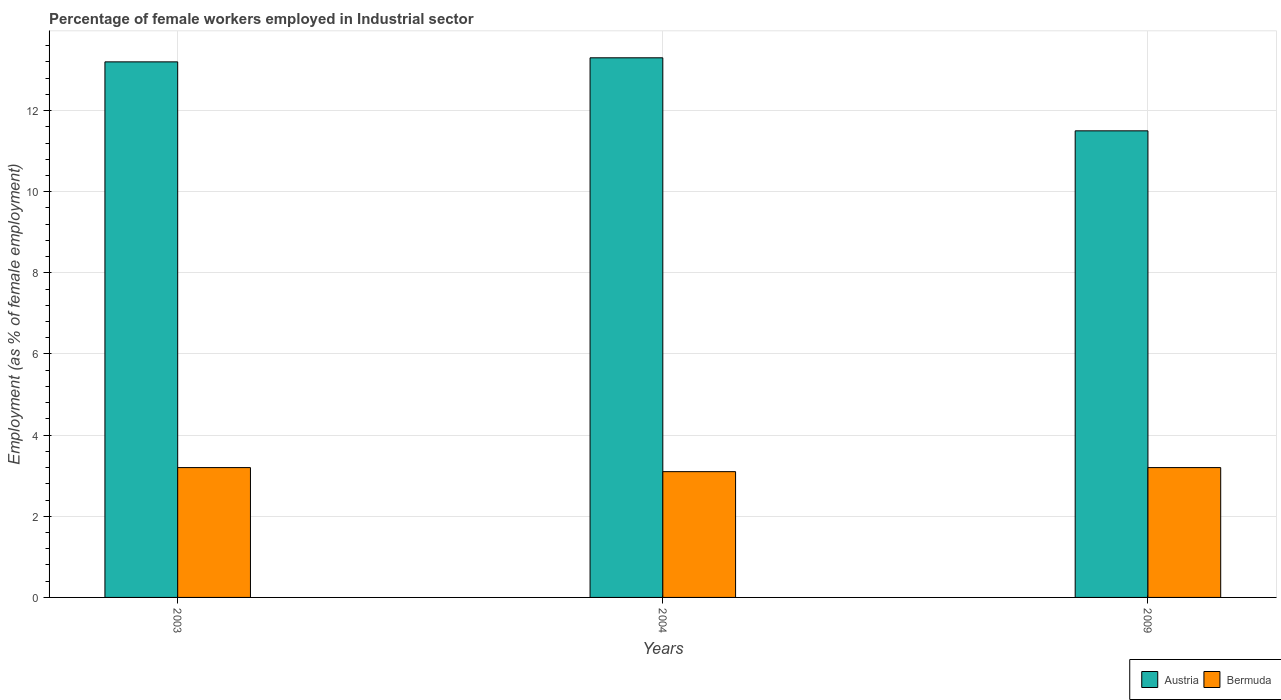How many groups of bars are there?
Offer a very short reply. 3. Are the number of bars on each tick of the X-axis equal?
Offer a very short reply. Yes. How many bars are there on the 1st tick from the right?
Your response must be concise. 2. In how many cases, is the number of bars for a given year not equal to the number of legend labels?
Make the answer very short. 0. What is the percentage of females employed in Industrial sector in Austria in 2003?
Keep it short and to the point. 13.2. Across all years, what is the maximum percentage of females employed in Industrial sector in Austria?
Your answer should be very brief. 13.3. Across all years, what is the minimum percentage of females employed in Industrial sector in Austria?
Ensure brevity in your answer.  11.5. In which year was the percentage of females employed in Industrial sector in Bermuda maximum?
Ensure brevity in your answer.  2003. In which year was the percentage of females employed in Industrial sector in Bermuda minimum?
Your response must be concise. 2004. What is the difference between the percentage of females employed in Industrial sector in Bermuda in 2004 and that in 2009?
Ensure brevity in your answer.  -0.1. What is the difference between the percentage of females employed in Industrial sector in Bermuda in 2003 and the percentage of females employed in Industrial sector in Austria in 2004?
Provide a short and direct response. -10.1. What is the average percentage of females employed in Industrial sector in Bermuda per year?
Your response must be concise. 3.17. In the year 2009, what is the difference between the percentage of females employed in Industrial sector in Bermuda and percentage of females employed in Industrial sector in Austria?
Offer a terse response. -8.3. In how many years, is the percentage of females employed in Industrial sector in Austria greater than 12.8 %?
Provide a succinct answer. 2. What is the ratio of the percentage of females employed in Industrial sector in Austria in 2004 to that in 2009?
Your answer should be very brief. 1.16. Is the difference between the percentage of females employed in Industrial sector in Bermuda in 2003 and 2009 greater than the difference between the percentage of females employed in Industrial sector in Austria in 2003 and 2009?
Make the answer very short. No. What is the difference between the highest and the second highest percentage of females employed in Industrial sector in Austria?
Your answer should be compact. 0.1. What is the difference between the highest and the lowest percentage of females employed in Industrial sector in Austria?
Offer a terse response. 1.8. In how many years, is the percentage of females employed in Industrial sector in Austria greater than the average percentage of females employed in Industrial sector in Austria taken over all years?
Keep it short and to the point. 2. Is the sum of the percentage of females employed in Industrial sector in Austria in 2004 and 2009 greater than the maximum percentage of females employed in Industrial sector in Bermuda across all years?
Offer a terse response. Yes. What does the 2nd bar from the left in 2004 represents?
Offer a terse response. Bermuda. What does the 1st bar from the right in 2009 represents?
Make the answer very short. Bermuda. Are all the bars in the graph horizontal?
Your answer should be very brief. No. How many years are there in the graph?
Provide a short and direct response. 3. What is the difference between two consecutive major ticks on the Y-axis?
Your response must be concise. 2. Does the graph contain any zero values?
Your response must be concise. No. What is the title of the graph?
Make the answer very short. Percentage of female workers employed in Industrial sector. What is the label or title of the X-axis?
Your answer should be very brief. Years. What is the label or title of the Y-axis?
Provide a succinct answer. Employment (as % of female employment). What is the Employment (as % of female employment) of Austria in 2003?
Keep it short and to the point. 13.2. What is the Employment (as % of female employment) in Bermuda in 2003?
Your answer should be compact. 3.2. What is the Employment (as % of female employment) in Austria in 2004?
Make the answer very short. 13.3. What is the Employment (as % of female employment) of Bermuda in 2004?
Offer a terse response. 3.1. What is the Employment (as % of female employment) in Bermuda in 2009?
Your answer should be compact. 3.2. Across all years, what is the maximum Employment (as % of female employment) in Austria?
Offer a terse response. 13.3. Across all years, what is the maximum Employment (as % of female employment) in Bermuda?
Ensure brevity in your answer.  3.2. Across all years, what is the minimum Employment (as % of female employment) in Austria?
Make the answer very short. 11.5. Across all years, what is the minimum Employment (as % of female employment) in Bermuda?
Ensure brevity in your answer.  3.1. What is the total Employment (as % of female employment) in Bermuda in the graph?
Make the answer very short. 9.5. What is the difference between the Employment (as % of female employment) in Bermuda in 2003 and that in 2009?
Give a very brief answer. 0. What is the difference between the Employment (as % of female employment) of Bermuda in 2004 and that in 2009?
Keep it short and to the point. -0.1. What is the average Employment (as % of female employment) of Austria per year?
Offer a terse response. 12.67. What is the average Employment (as % of female employment) of Bermuda per year?
Ensure brevity in your answer.  3.17. In the year 2003, what is the difference between the Employment (as % of female employment) in Austria and Employment (as % of female employment) in Bermuda?
Your response must be concise. 10. In the year 2004, what is the difference between the Employment (as % of female employment) of Austria and Employment (as % of female employment) of Bermuda?
Your response must be concise. 10.2. What is the ratio of the Employment (as % of female employment) in Austria in 2003 to that in 2004?
Keep it short and to the point. 0.99. What is the ratio of the Employment (as % of female employment) of Bermuda in 2003 to that in 2004?
Your answer should be very brief. 1.03. What is the ratio of the Employment (as % of female employment) of Austria in 2003 to that in 2009?
Offer a terse response. 1.15. What is the ratio of the Employment (as % of female employment) in Bermuda in 2003 to that in 2009?
Ensure brevity in your answer.  1. What is the ratio of the Employment (as % of female employment) of Austria in 2004 to that in 2009?
Your answer should be compact. 1.16. What is the ratio of the Employment (as % of female employment) in Bermuda in 2004 to that in 2009?
Provide a short and direct response. 0.97. What is the difference between the highest and the lowest Employment (as % of female employment) in Austria?
Your answer should be compact. 1.8. What is the difference between the highest and the lowest Employment (as % of female employment) of Bermuda?
Provide a succinct answer. 0.1. 